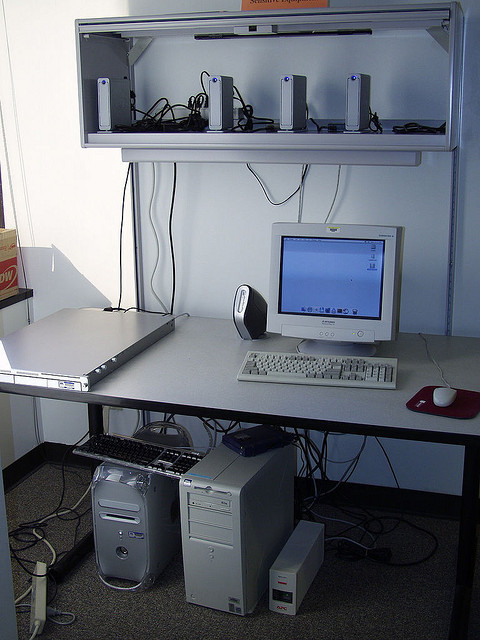<image>Where is the printer? I don't know where the printer is located. It can be on the desk or under the desk. Where is the printer? The printer is not visible in the image. However, it can be found under the desk. 